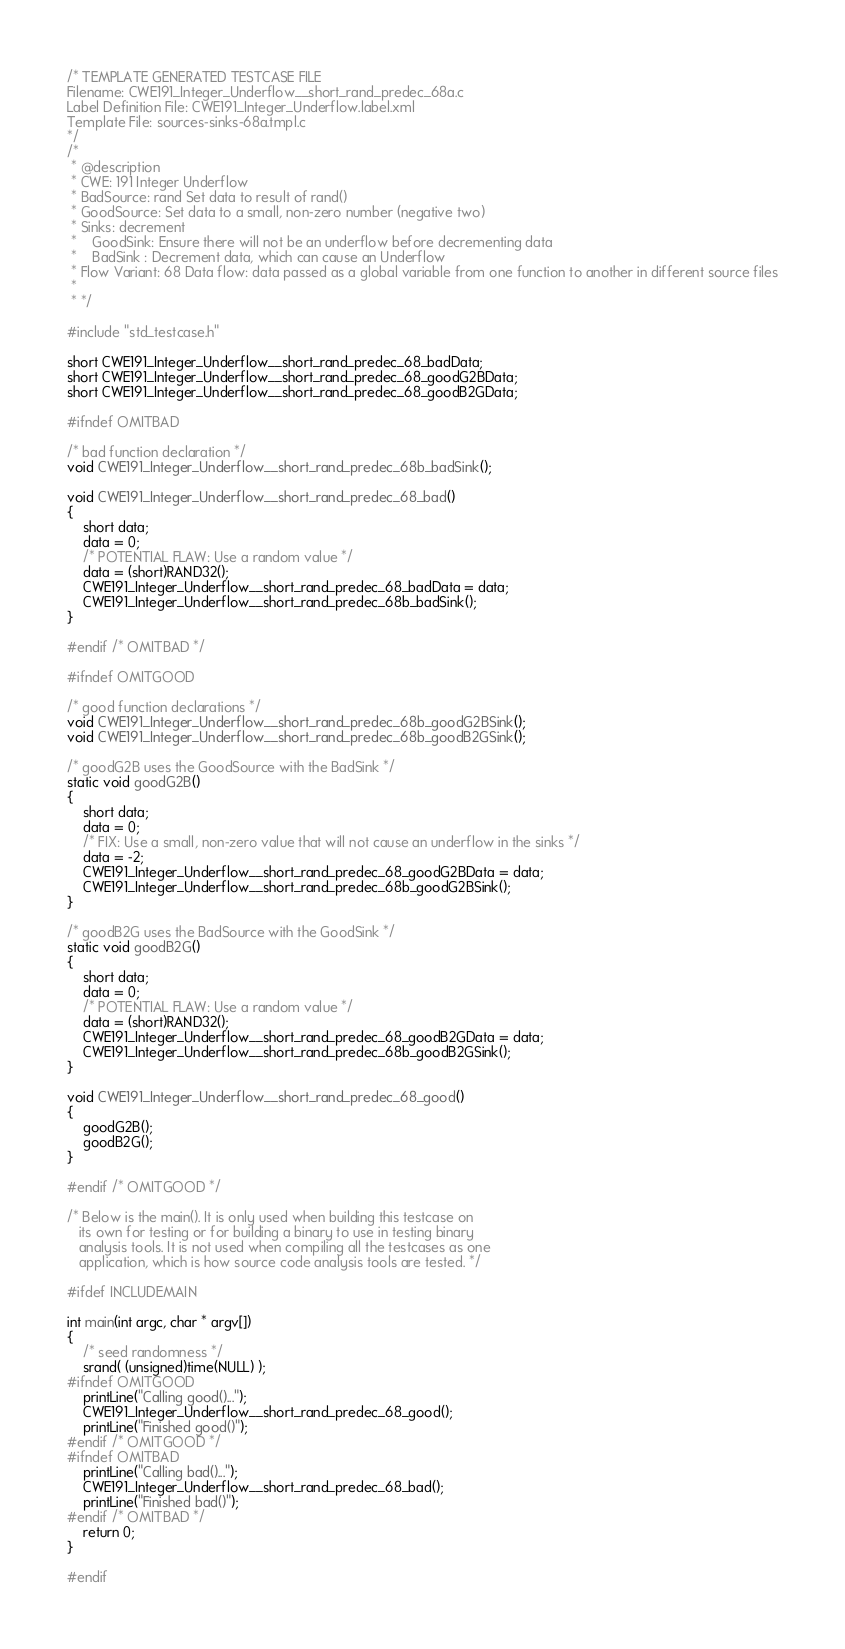<code> <loc_0><loc_0><loc_500><loc_500><_C_>/* TEMPLATE GENERATED TESTCASE FILE
Filename: CWE191_Integer_Underflow__short_rand_predec_68a.c
Label Definition File: CWE191_Integer_Underflow.label.xml
Template File: sources-sinks-68a.tmpl.c
*/
/*
 * @description
 * CWE: 191 Integer Underflow
 * BadSource: rand Set data to result of rand()
 * GoodSource: Set data to a small, non-zero number (negative two)
 * Sinks: decrement
 *    GoodSink: Ensure there will not be an underflow before decrementing data
 *    BadSink : Decrement data, which can cause an Underflow
 * Flow Variant: 68 Data flow: data passed as a global variable from one function to another in different source files
 *
 * */

#include "std_testcase.h"

short CWE191_Integer_Underflow__short_rand_predec_68_badData;
short CWE191_Integer_Underflow__short_rand_predec_68_goodG2BData;
short CWE191_Integer_Underflow__short_rand_predec_68_goodB2GData;

#ifndef OMITBAD

/* bad function declaration */
void CWE191_Integer_Underflow__short_rand_predec_68b_badSink();

void CWE191_Integer_Underflow__short_rand_predec_68_bad()
{
    short data;
    data = 0;
    /* POTENTIAL FLAW: Use a random value */
    data = (short)RAND32();
    CWE191_Integer_Underflow__short_rand_predec_68_badData = data;
    CWE191_Integer_Underflow__short_rand_predec_68b_badSink();
}

#endif /* OMITBAD */

#ifndef OMITGOOD

/* good function declarations */
void CWE191_Integer_Underflow__short_rand_predec_68b_goodG2BSink();
void CWE191_Integer_Underflow__short_rand_predec_68b_goodB2GSink();

/* goodG2B uses the GoodSource with the BadSink */
static void goodG2B()
{
    short data;
    data = 0;
    /* FIX: Use a small, non-zero value that will not cause an underflow in the sinks */
    data = -2;
    CWE191_Integer_Underflow__short_rand_predec_68_goodG2BData = data;
    CWE191_Integer_Underflow__short_rand_predec_68b_goodG2BSink();
}

/* goodB2G uses the BadSource with the GoodSink */
static void goodB2G()
{
    short data;
    data = 0;
    /* POTENTIAL FLAW: Use a random value */
    data = (short)RAND32();
    CWE191_Integer_Underflow__short_rand_predec_68_goodB2GData = data;
    CWE191_Integer_Underflow__short_rand_predec_68b_goodB2GSink();
}

void CWE191_Integer_Underflow__short_rand_predec_68_good()
{
    goodG2B();
    goodB2G();
}

#endif /* OMITGOOD */

/* Below is the main(). It is only used when building this testcase on
   its own for testing or for building a binary to use in testing binary
   analysis tools. It is not used when compiling all the testcases as one
   application, which is how source code analysis tools are tested. */

#ifdef INCLUDEMAIN

int main(int argc, char * argv[])
{
    /* seed randomness */
    srand( (unsigned)time(NULL) );
#ifndef OMITGOOD
    printLine("Calling good()...");
    CWE191_Integer_Underflow__short_rand_predec_68_good();
    printLine("Finished good()");
#endif /* OMITGOOD */
#ifndef OMITBAD
    printLine("Calling bad()...");
    CWE191_Integer_Underflow__short_rand_predec_68_bad();
    printLine("Finished bad()");
#endif /* OMITBAD */
    return 0;
}

#endif
</code> 